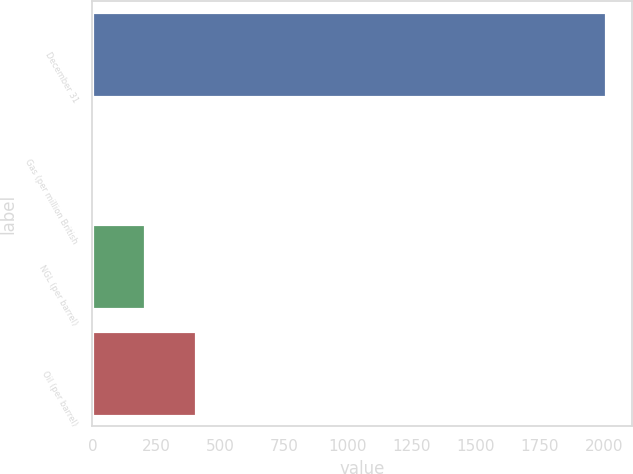<chart> <loc_0><loc_0><loc_500><loc_500><bar_chart><fcel>December 31<fcel>Gas (per million British<fcel>NGL (per barrel)<fcel>Oil (per barrel)<nl><fcel>2009<fcel>3.87<fcel>204.38<fcel>404.89<nl></chart> 